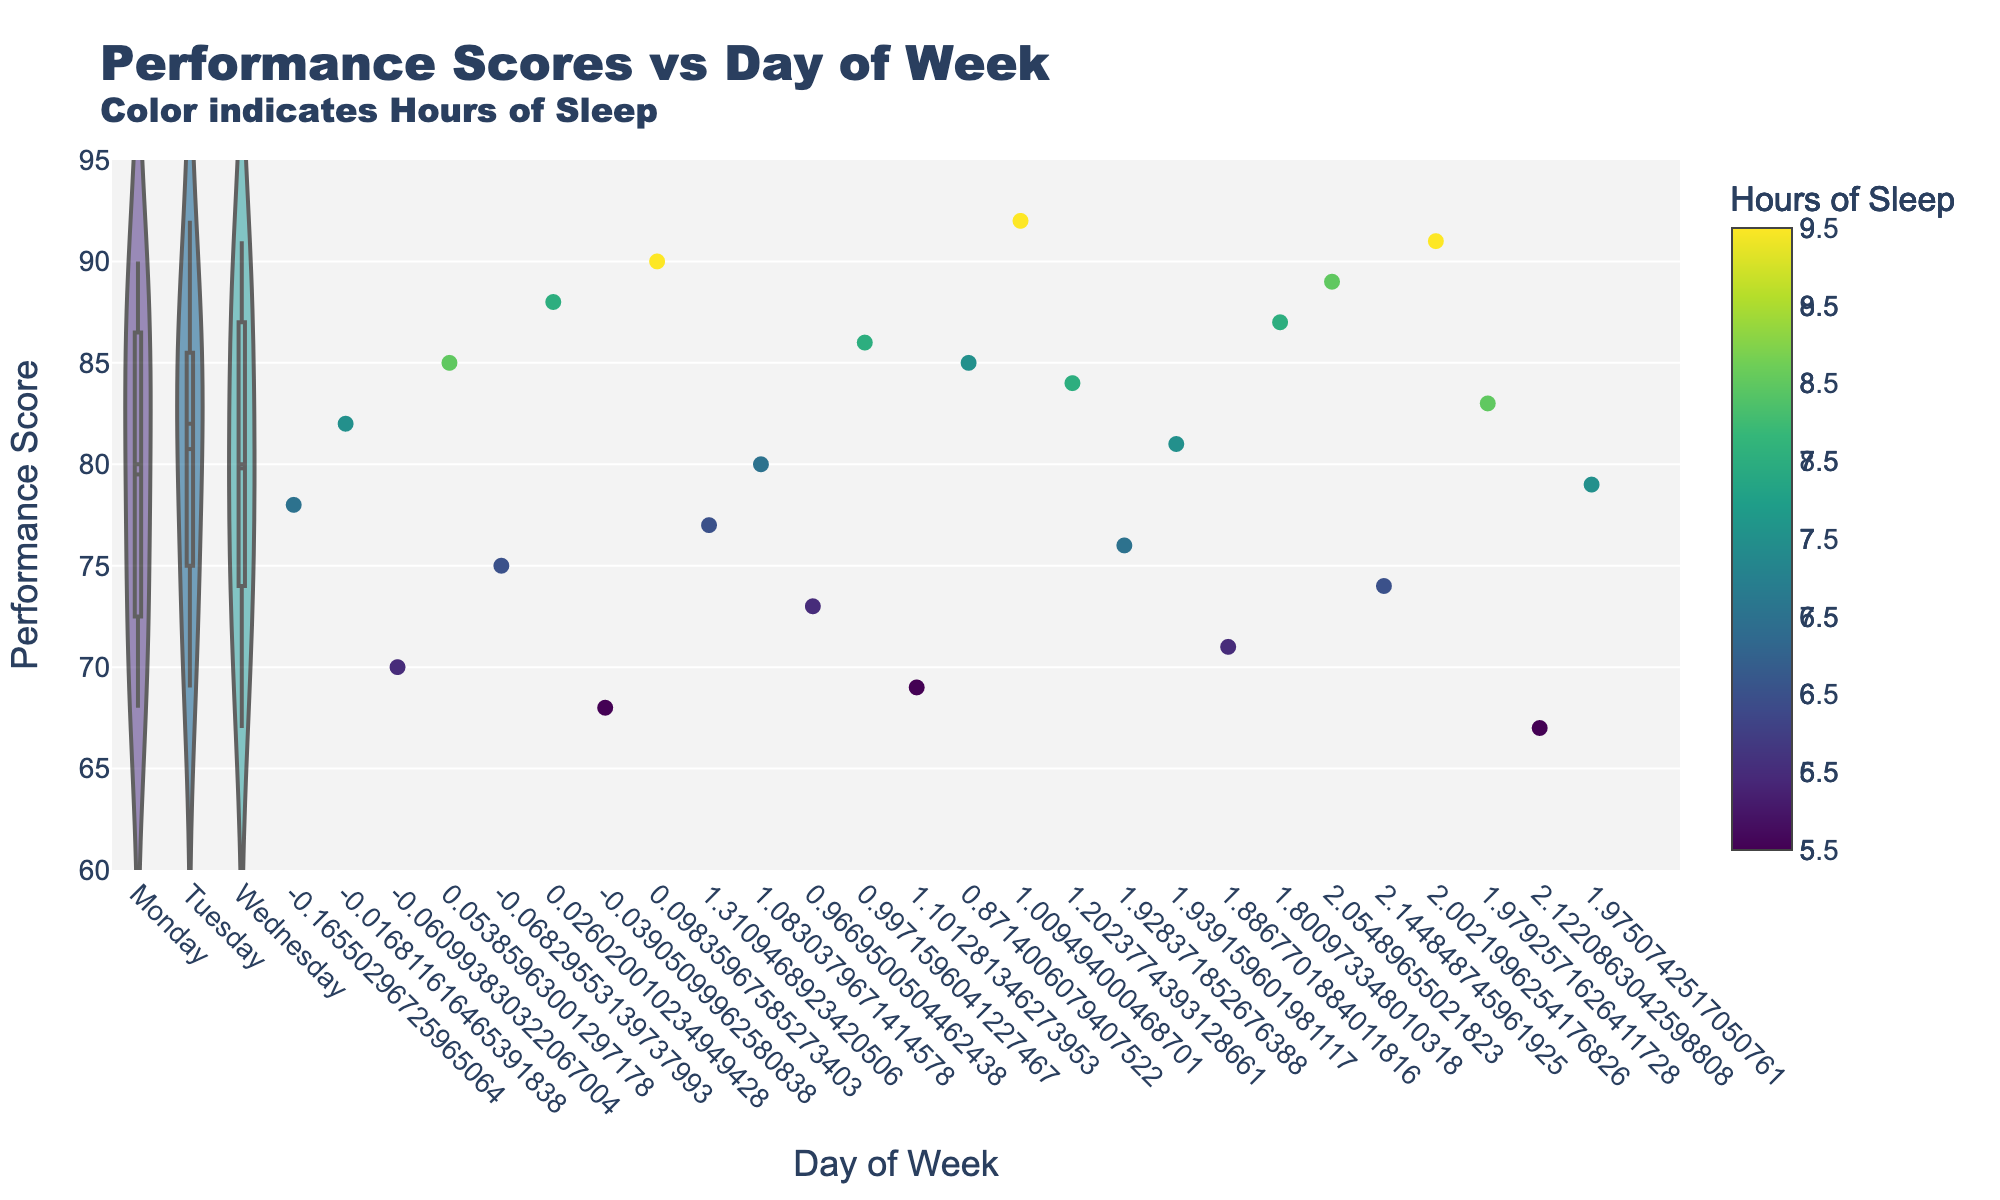What's the title of the figure? The title is displayed at the top of the figure. It reads "Performance Scores vs Day of Week" with a sub-title indicating that color represents "Hours of Sleep".
Answer: Performance Scores vs Day of Week What does the color of the jittered points represent? The color of the jittered points is indicated by the colorbar on the right side of the figure. The title of the colorbar states that it represents the "Hours of Sleep".
Answer: Hours of Sleep Which day of the week shows the highest maximum performance score in the violin plot? By observing the upper most points of the violin plots, Wednesday shows the highest maximum performance score, which is around 91.
Answer: Wednesday How do the performance scores on Monday and Tuesday compare? By visually comparing the ranges and the mean lines in the violin plots for Monday and Tuesday, it's observed that Monday's performance scores range from about 68 to 90 with an average around 80, while Tuesday's scores are slightly higher, ranging from about 67 to 92 with an average around 85.
Answer: Scores on Tuesday are generally higher What is the average performance score on Monday? The meanline within the violin plot on Monday indicates the average performance score. It appears to be around 80.
Answer: About 80 Does more sleep generally lead to better performance scores? By observing the color gradient in relation to performance scores, darker points (indicating more sleep) generally appear higher on the y-axis, showing higher performance scores.
Answer: Yes Which day of the week has the most consistent performance scores? Consistency can be assessed by the spread of the data points within the violin plot. Wednesday shows a narrow spread, meaning performance scores are more consistent.
Answer: Wednesday What is the lowest performance score recorded, and on which day did it occur? The lowest point across all violin plots indicates the lowest performance score. It is around 67 on Wednesday.
Answer: 67, Wednesday 